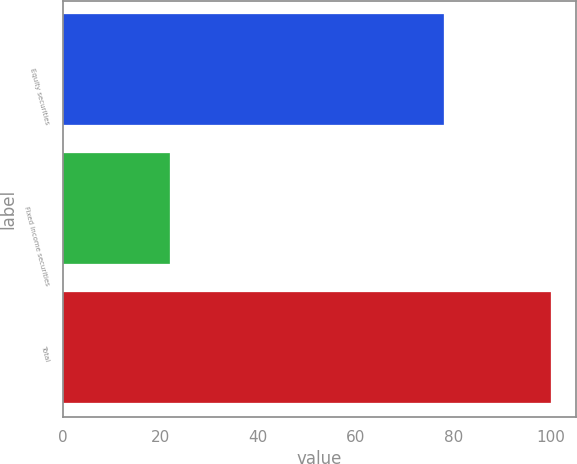Convert chart. <chart><loc_0><loc_0><loc_500><loc_500><bar_chart><fcel>Equity securities<fcel>Fixed income securities<fcel>Total<nl><fcel>78<fcel>22<fcel>100<nl></chart> 